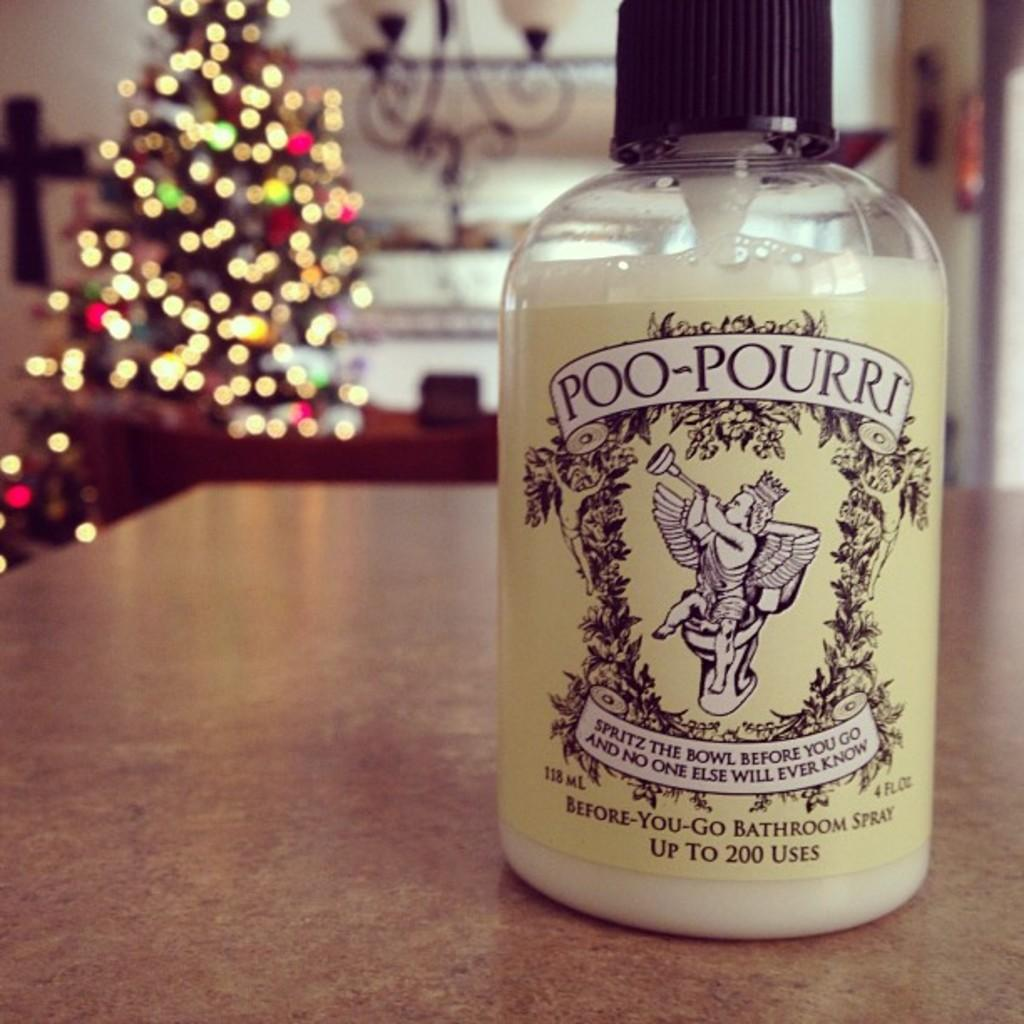What is inside the bottle that has a label in the image? There is liquid in the bottle. What can be seen next to the bottle in the image? There is an x-mas tree visible in the image. What type of joke is being told by the engine in the image? There is no engine or joke present in the image. Where is the train station located in the image? There is no train station present in the image. 